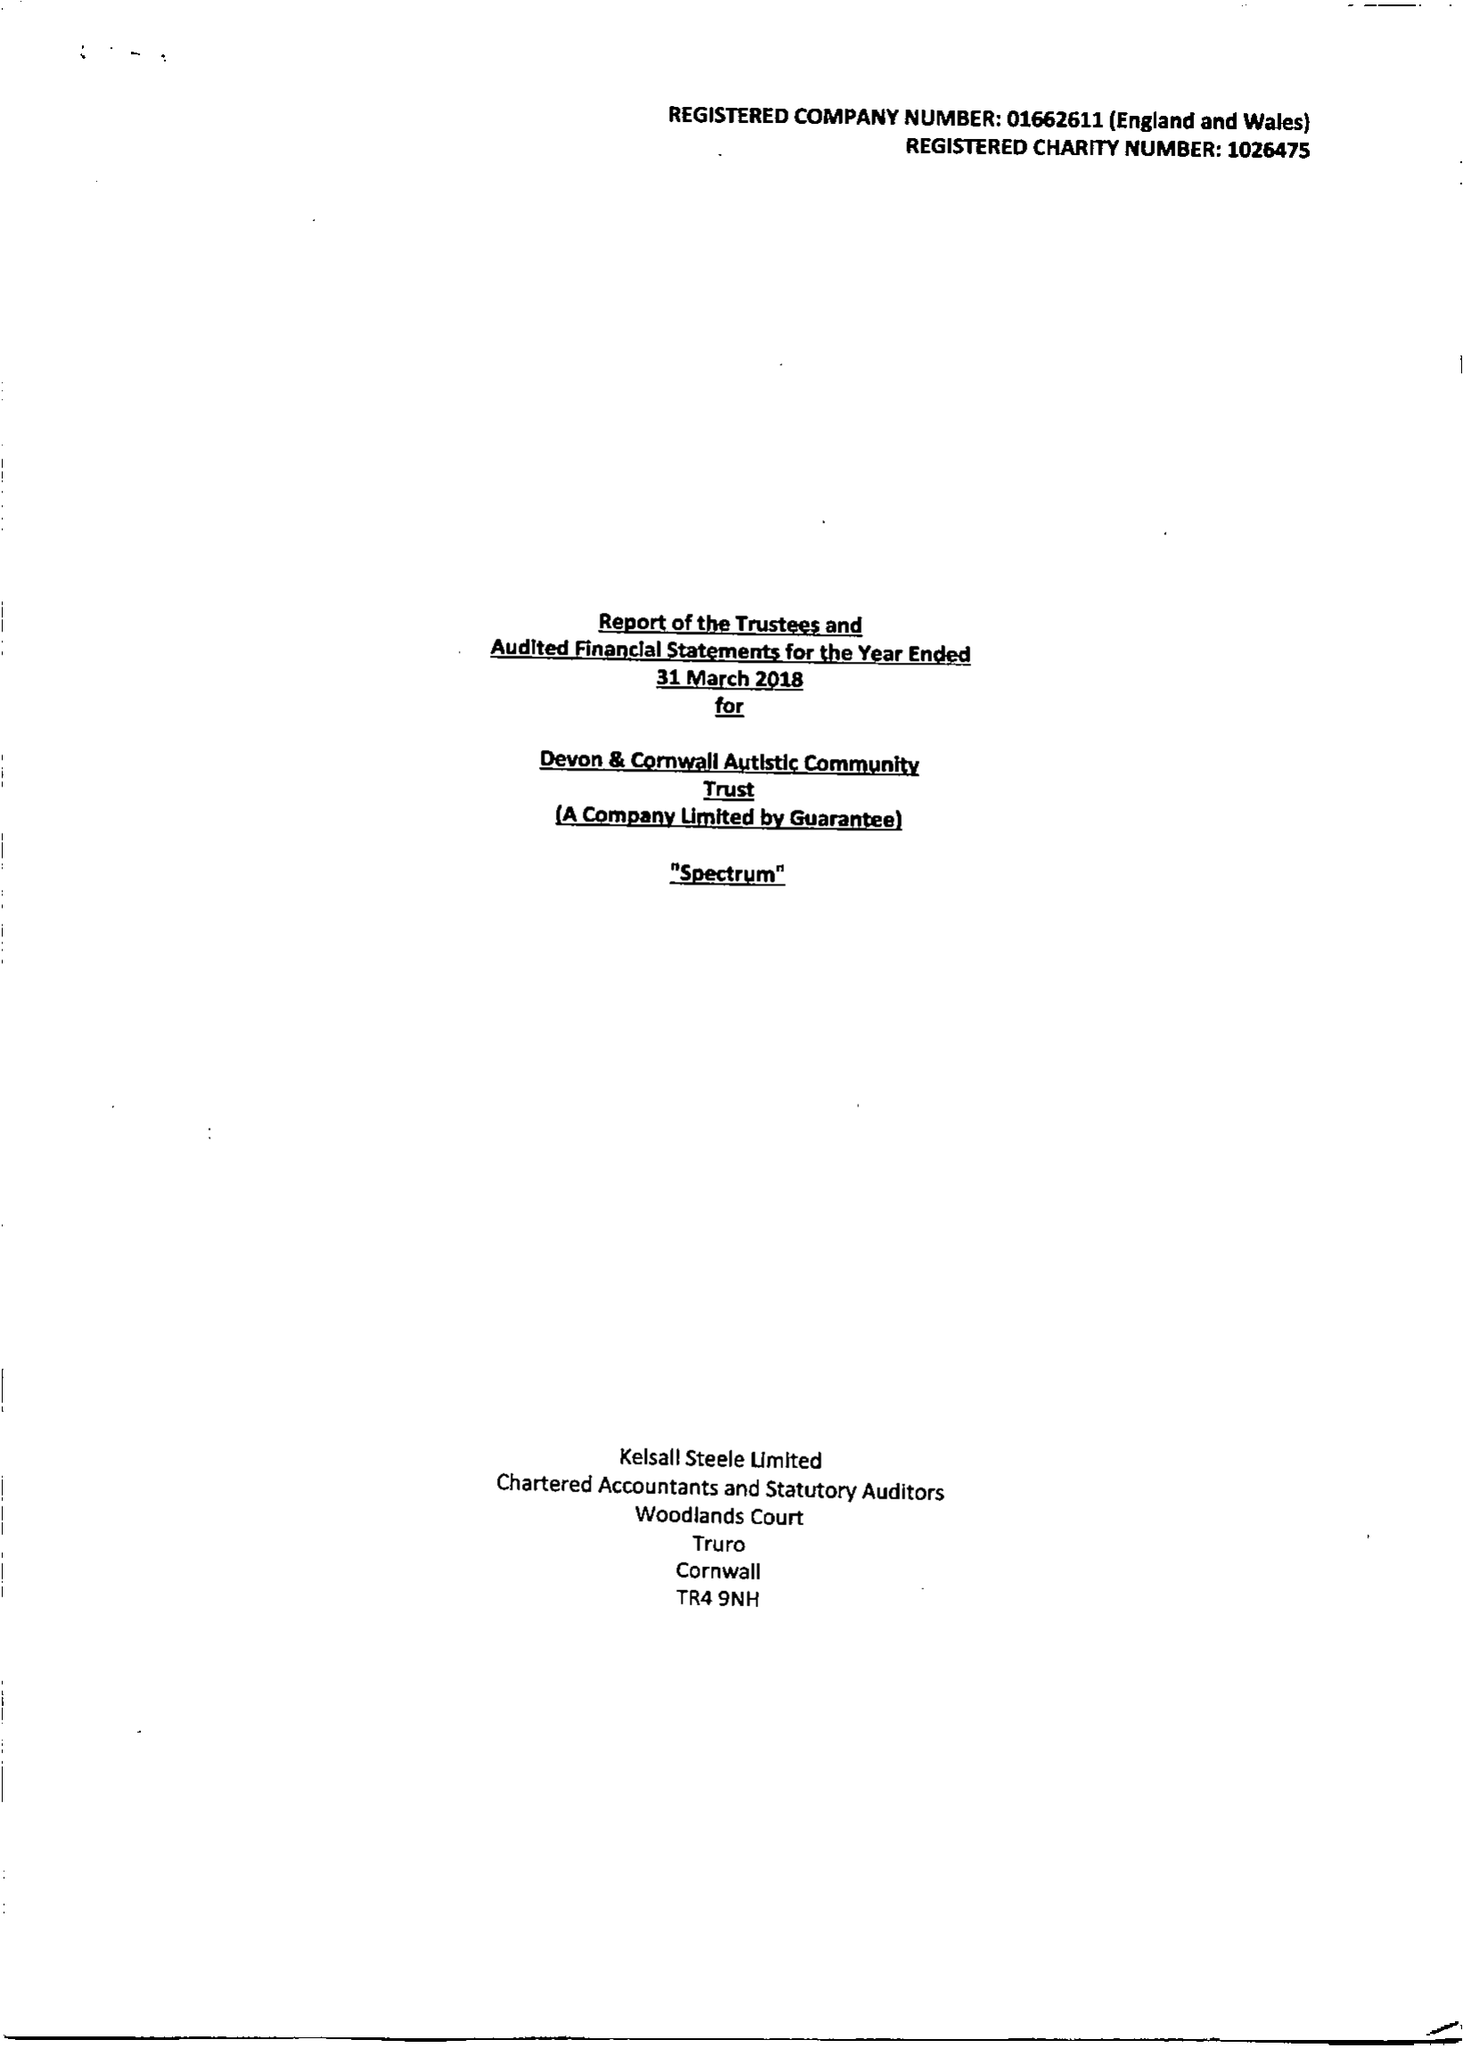What is the value for the spending_annually_in_british_pounds?
Answer the question using a single word or phrase. 11253306.00 